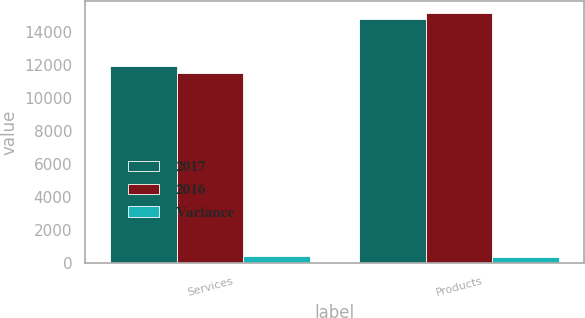Convert chart. <chart><loc_0><loc_0><loc_500><loc_500><stacked_bar_chart><ecel><fcel>Services<fcel>Products<nl><fcel>2017<fcel>11957<fcel>14799<nl><fcel>2016<fcel>11551<fcel>15159<nl><fcel>Variance<fcel>406<fcel>360<nl></chart> 